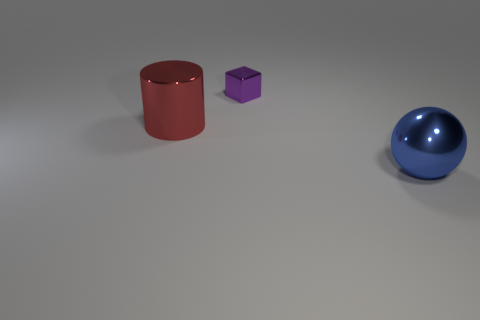Are there any other large cylinders that have the same material as the cylinder?
Your answer should be compact. No. There is a metallic object that is on the left side of the tiny purple shiny thing; does it have the same color as the thing that is on the right side of the tiny purple metallic thing?
Offer a very short reply. No. Are there fewer shiny things that are in front of the small block than big gray objects?
Ensure brevity in your answer.  No. What number of things are tiny blocks or big metallic things that are in front of the big red object?
Give a very brief answer. 2. The small block that is the same material as the large cylinder is what color?
Give a very brief answer. Purple. What number of things are either large red metal cylinders or small green balls?
Offer a terse response. 1. What is the color of the metal cylinder that is the same size as the blue thing?
Provide a succinct answer. Red. What number of objects are large shiny objects on the left side of the large blue metallic ball or large metallic objects?
Your response must be concise. 2. What number of other objects are the same size as the block?
Offer a terse response. 0. How big is the metal thing that is behind the red object?
Offer a very short reply. Small. 